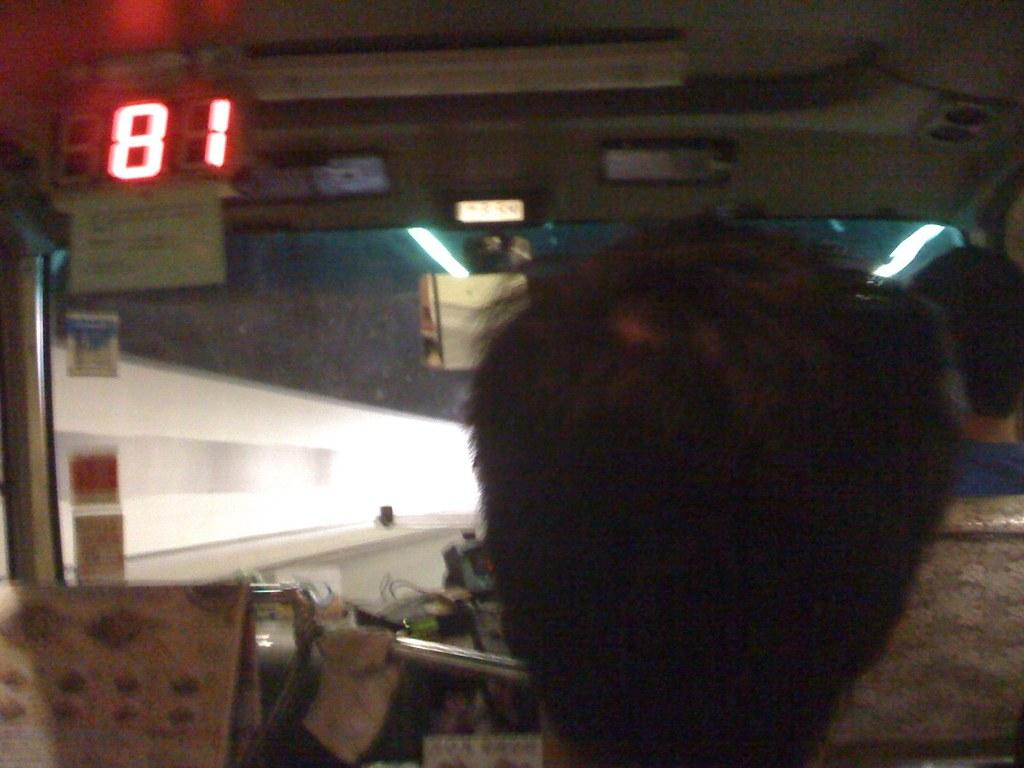What is the main subject of the image? The main subject of the image is a person sitting inside a vehicle. Can you describe any additional features of the vehicle? Yes, there is a light board on the left side of the vehicle in the image. What type of corn is being used to play chess on the calculator in the image? There is no corn, calculator, or chess game present in the image. 